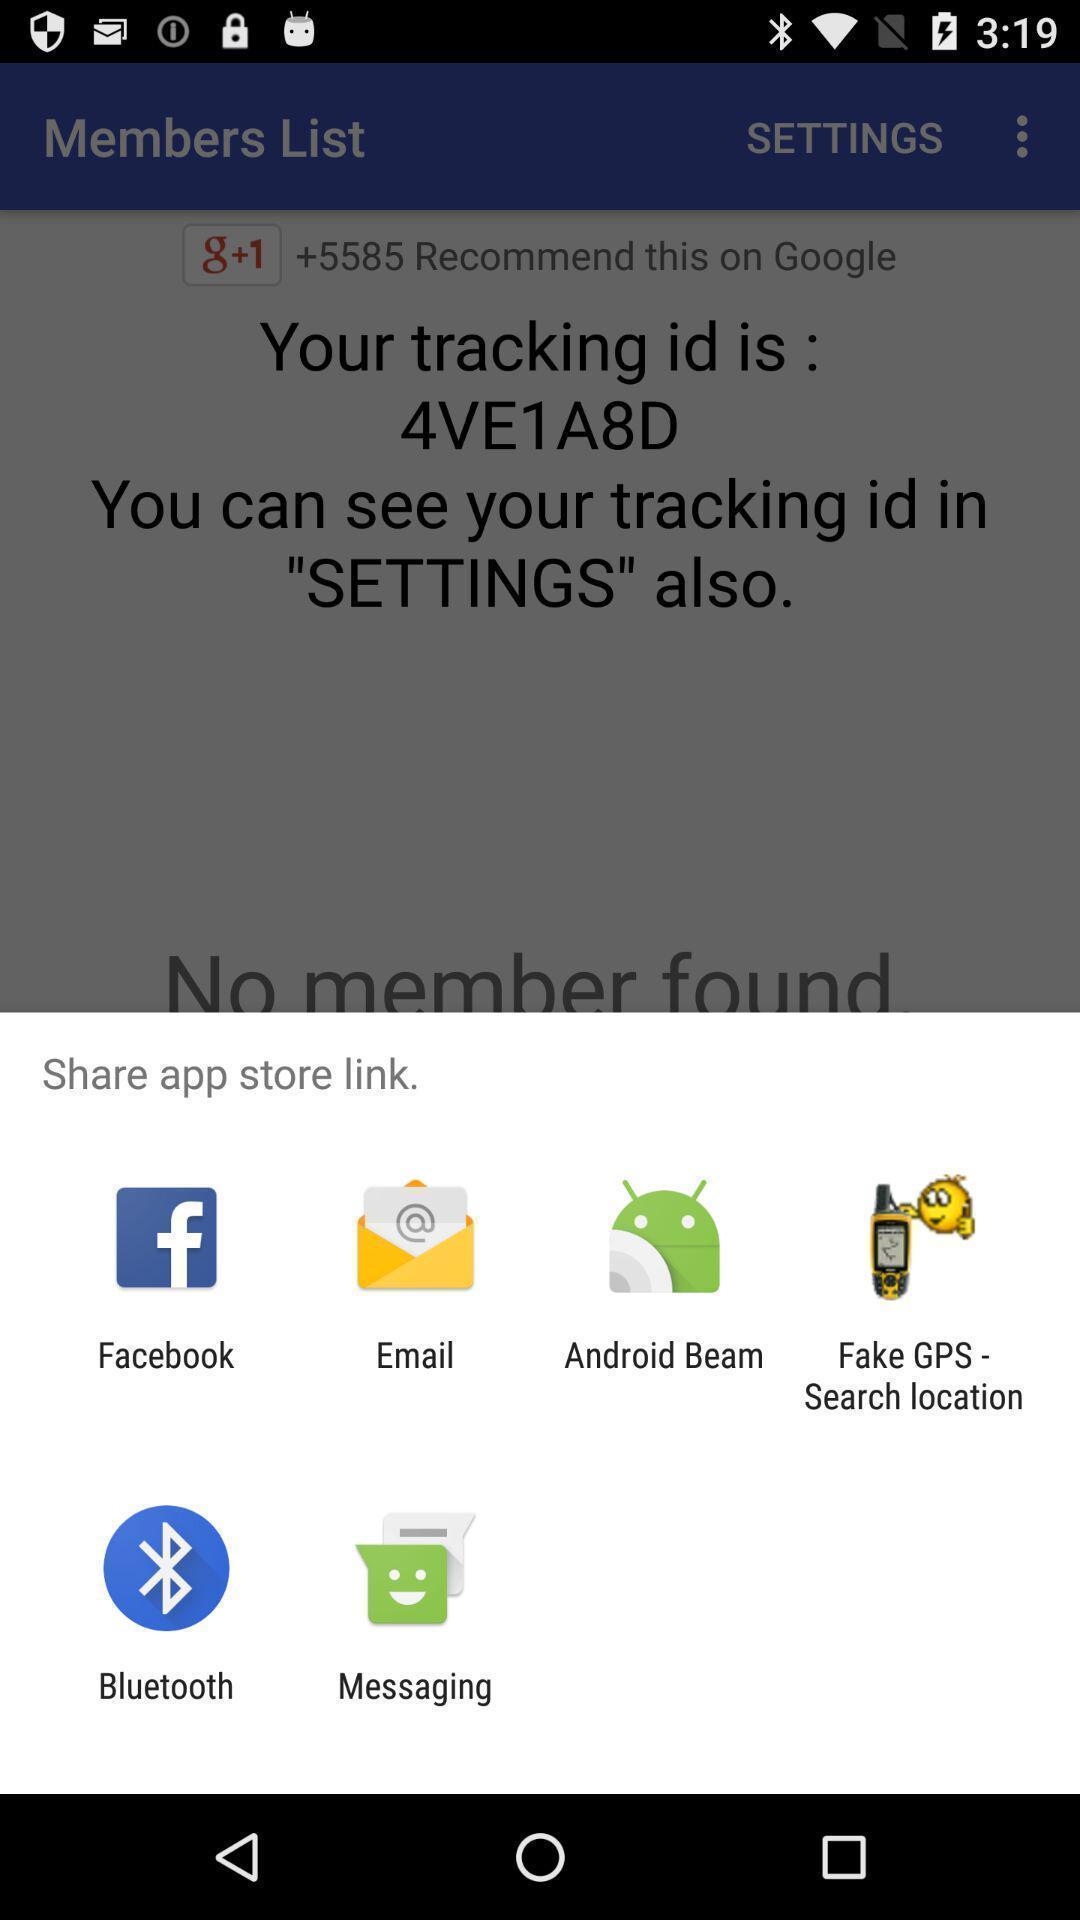Provide a detailed account of this screenshot. Pop-up displaying multiple applications to share. 